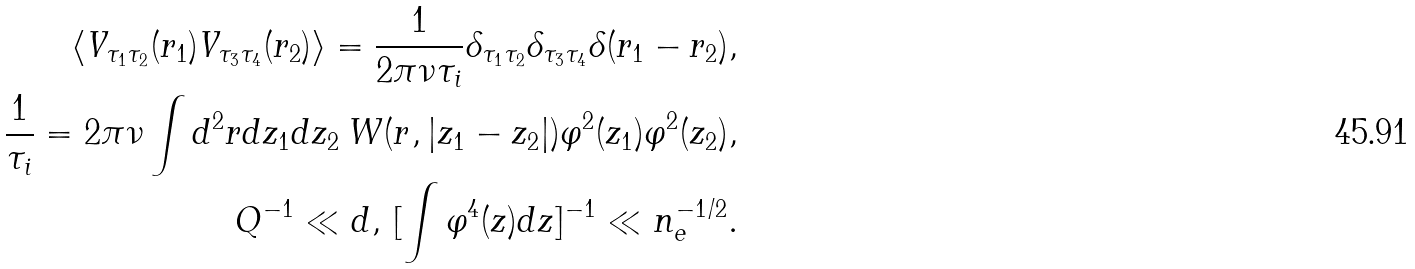<formula> <loc_0><loc_0><loc_500><loc_500>\langle V _ { \tau _ { 1 } \tau _ { 2 } } ( r _ { 1 } ) V _ { \tau _ { 3 } \tau _ { 4 } } ( r _ { 2 } ) \rangle = \frac { 1 } { 2 \pi \nu \tau _ { i } } \delta _ { \tau _ { 1 } \tau _ { 2 } } \delta _ { \tau _ { 3 } \tau _ { 4 } } \delta ( r _ { 1 } - r _ { 2 } ) , \\ \frac { 1 } { \tau _ { i } } = 2 \pi \nu \int d ^ { 2 } r d z _ { 1 } d z _ { 2 } \, W ( r , | z _ { 1 } - z _ { 2 } | ) \varphi ^ { 2 } ( z _ { 1 } ) \varphi ^ { 2 } ( z _ { 2 } ) , \\ Q ^ { - 1 } \ll d , \, [ \int \varphi ^ { 4 } ( z ) d z ] ^ { - 1 } \ll n _ { e } ^ { - 1 / 2 } .</formula> 